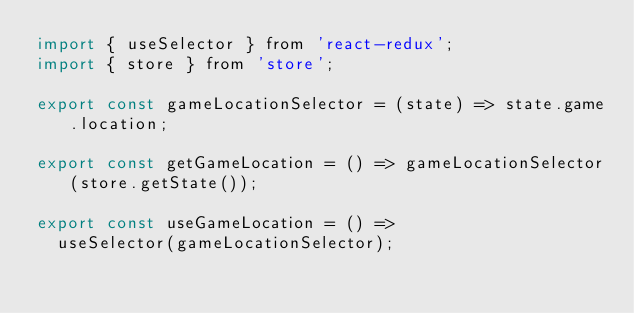Convert code to text. <code><loc_0><loc_0><loc_500><loc_500><_JavaScript_>import { useSelector } from 'react-redux';
import { store } from 'store';

export const gameLocationSelector = (state) => state.game.location;

export const getGameLocation = () => gameLocationSelector(store.getState());

export const useGameLocation = () =>
  useSelector(gameLocationSelector);
</code> 